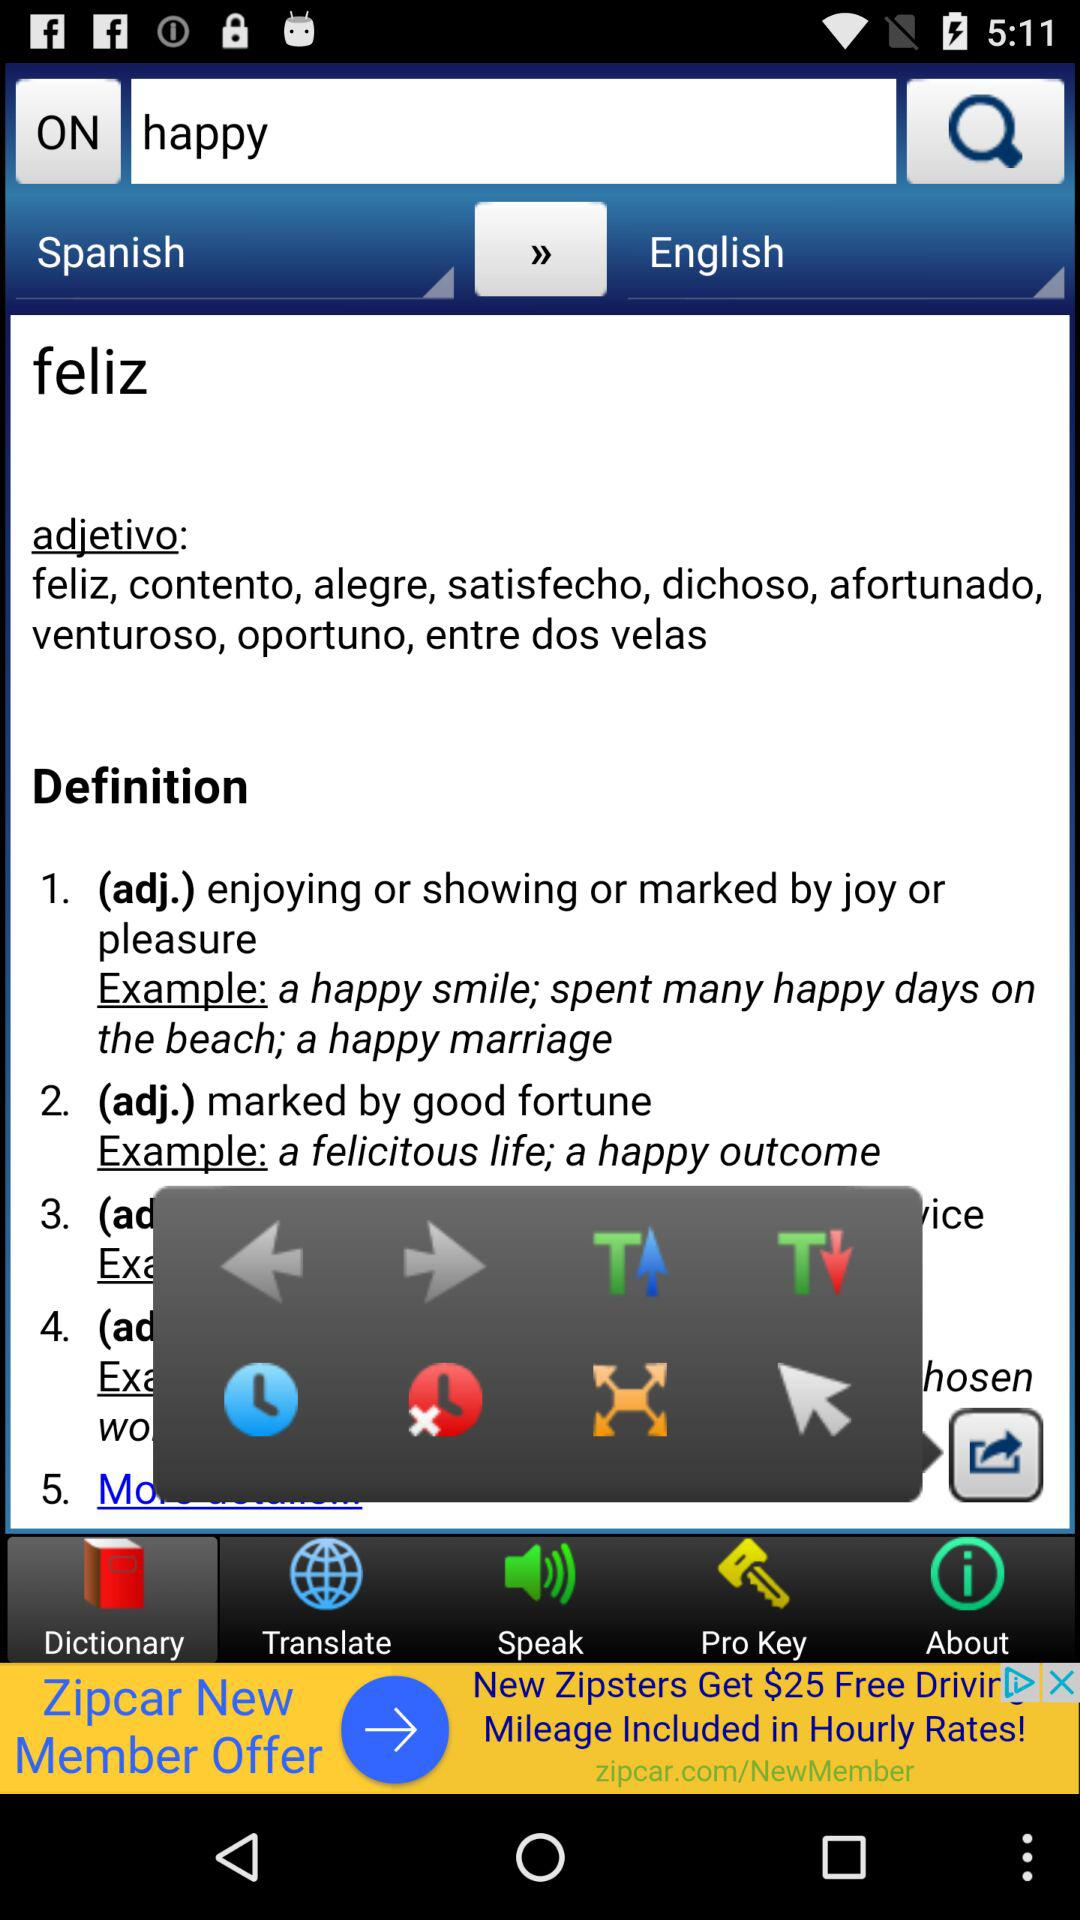Which tab is selected? The selected tab is "Dictionary". 